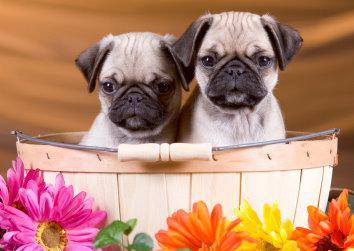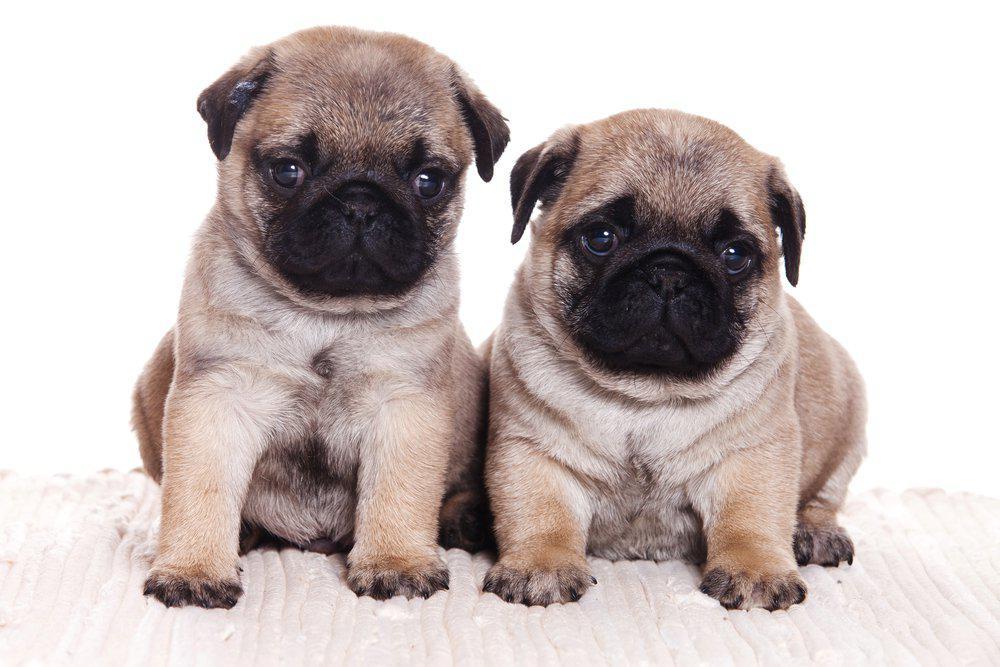The first image is the image on the left, the second image is the image on the right. Given the left and right images, does the statement "two pugs are wearing costumes" hold true? Answer yes or no. No. The first image is the image on the left, the second image is the image on the right. For the images displayed, is the sentence "Each image shows two buff-beige pugs with darker muzzles posed side-by-side facing forward." factually correct? Answer yes or no. Yes. 